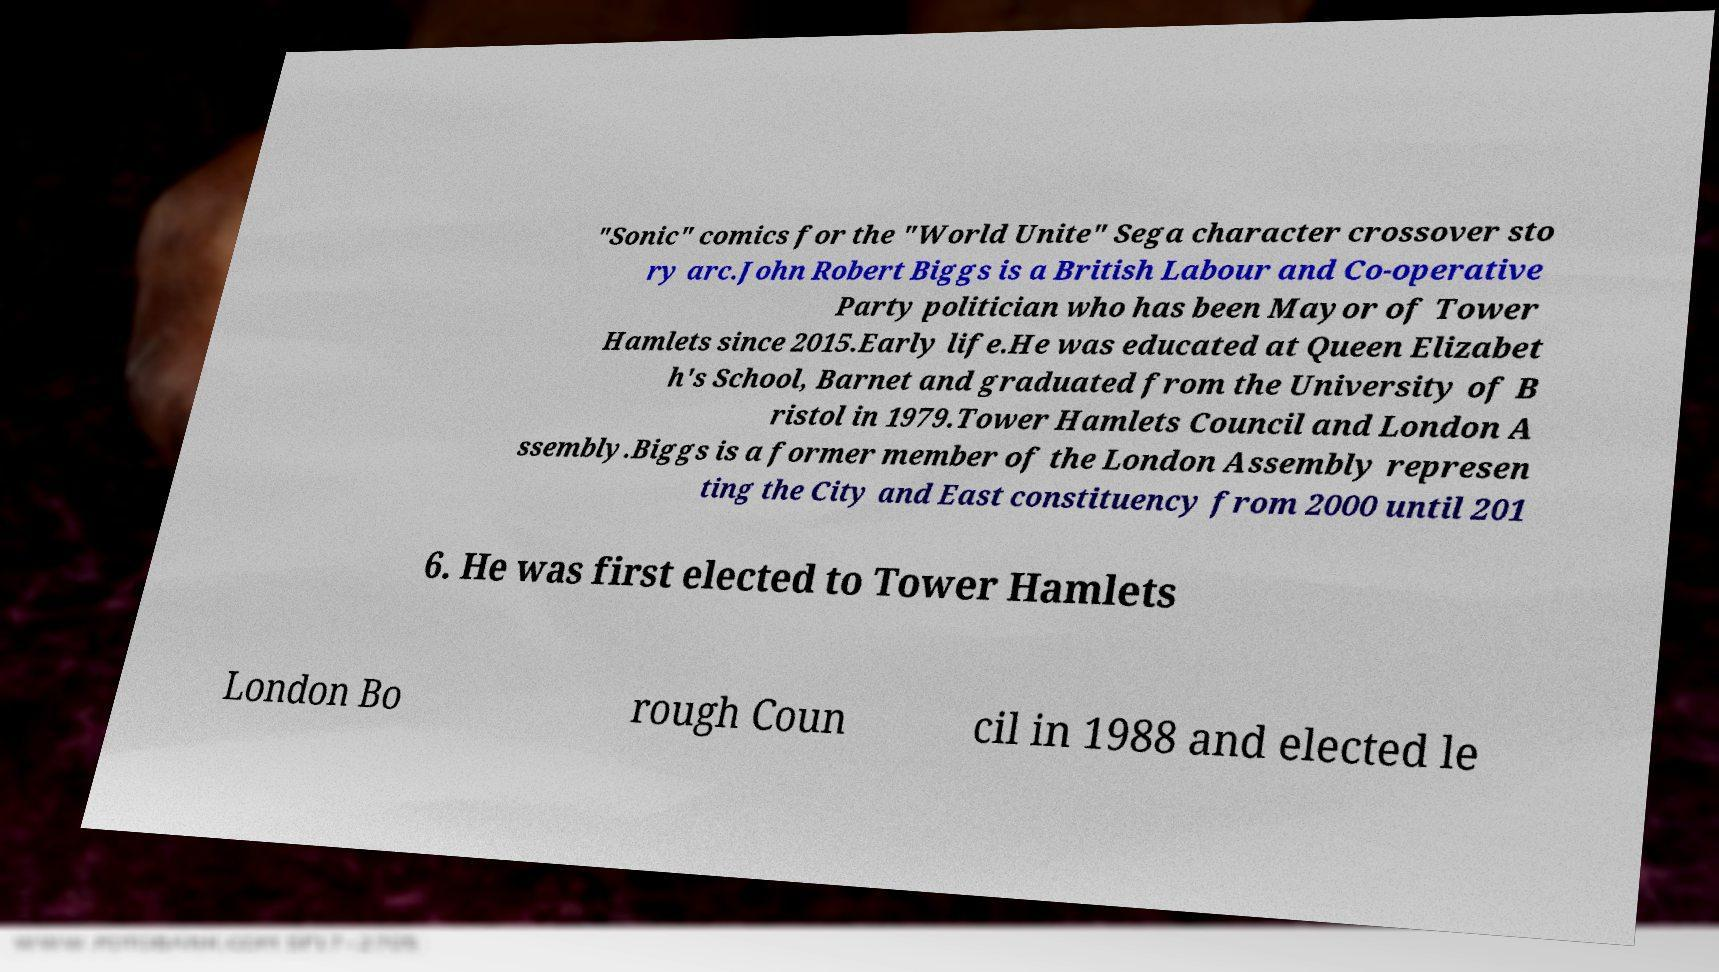Can you accurately transcribe the text from the provided image for me? "Sonic" comics for the "World Unite" Sega character crossover sto ry arc.John Robert Biggs is a British Labour and Co-operative Party politician who has been Mayor of Tower Hamlets since 2015.Early life.He was educated at Queen Elizabet h's School, Barnet and graduated from the University of B ristol in 1979.Tower Hamlets Council and London A ssembly.Biggs is a former member of the London Assembly represen ting the City and East constituency from 2000 until 201 6. He was first elected to Tower Hamlets London Bo rough Coun cil in 1988 and elected le 